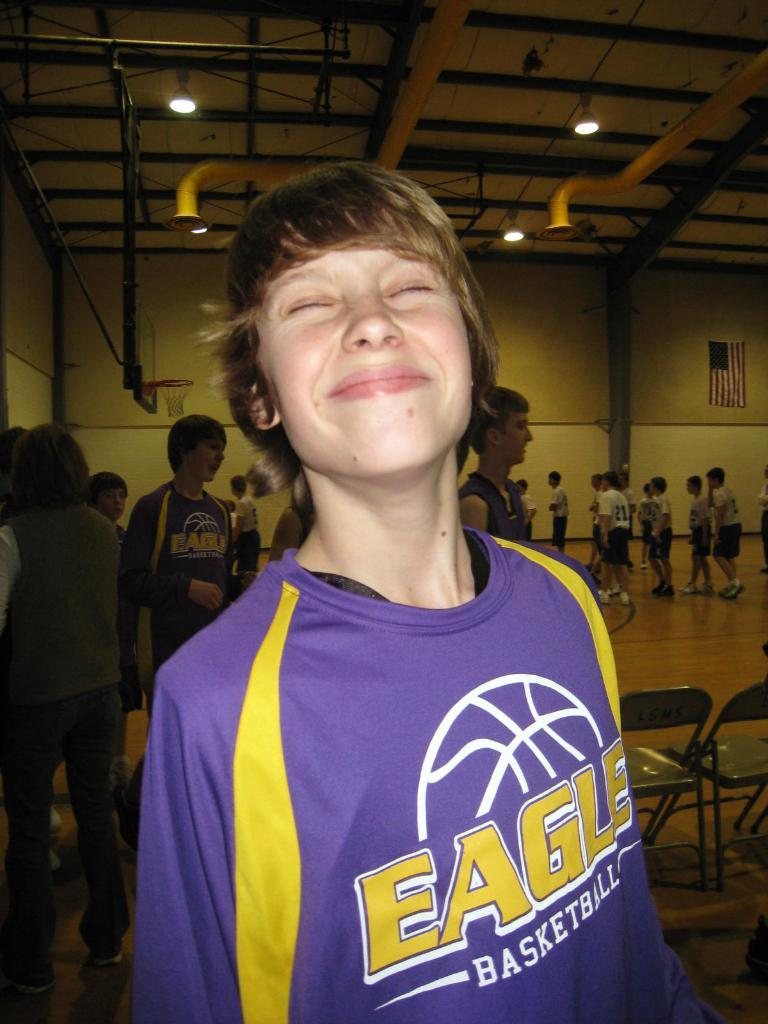Provide a one-sentence caption for the provided image. A boy wearing an Eagles Basketball jersey is smiling. 